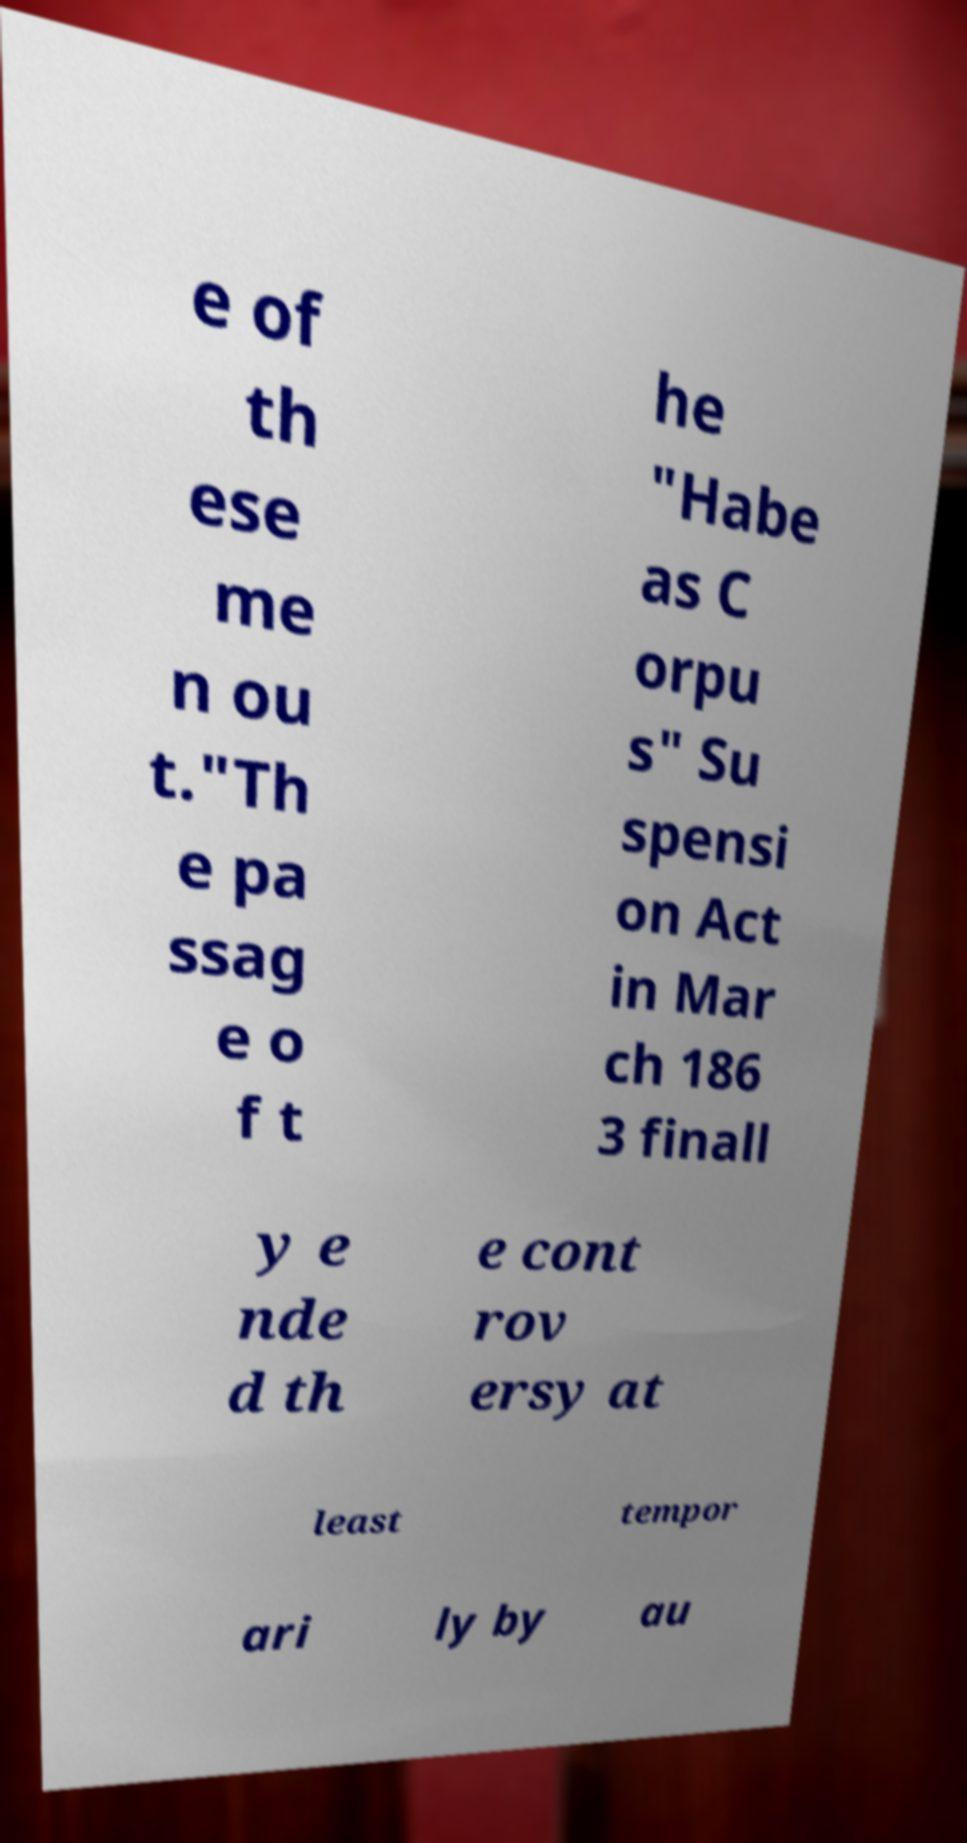Can you read and provide the text displayed in the image?This photo seems to have some interesting text. Can you extract and type it out for me? e of th ese me n ou t."Th e pa ssag e o f t he "Habe as C orpu s" Su spensi on Act in Mar ch 186 3 finall y e nde d th e cont rov ersy at least tempor ari ly by au 